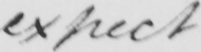Can you tell me what this handwritten text says? expect 